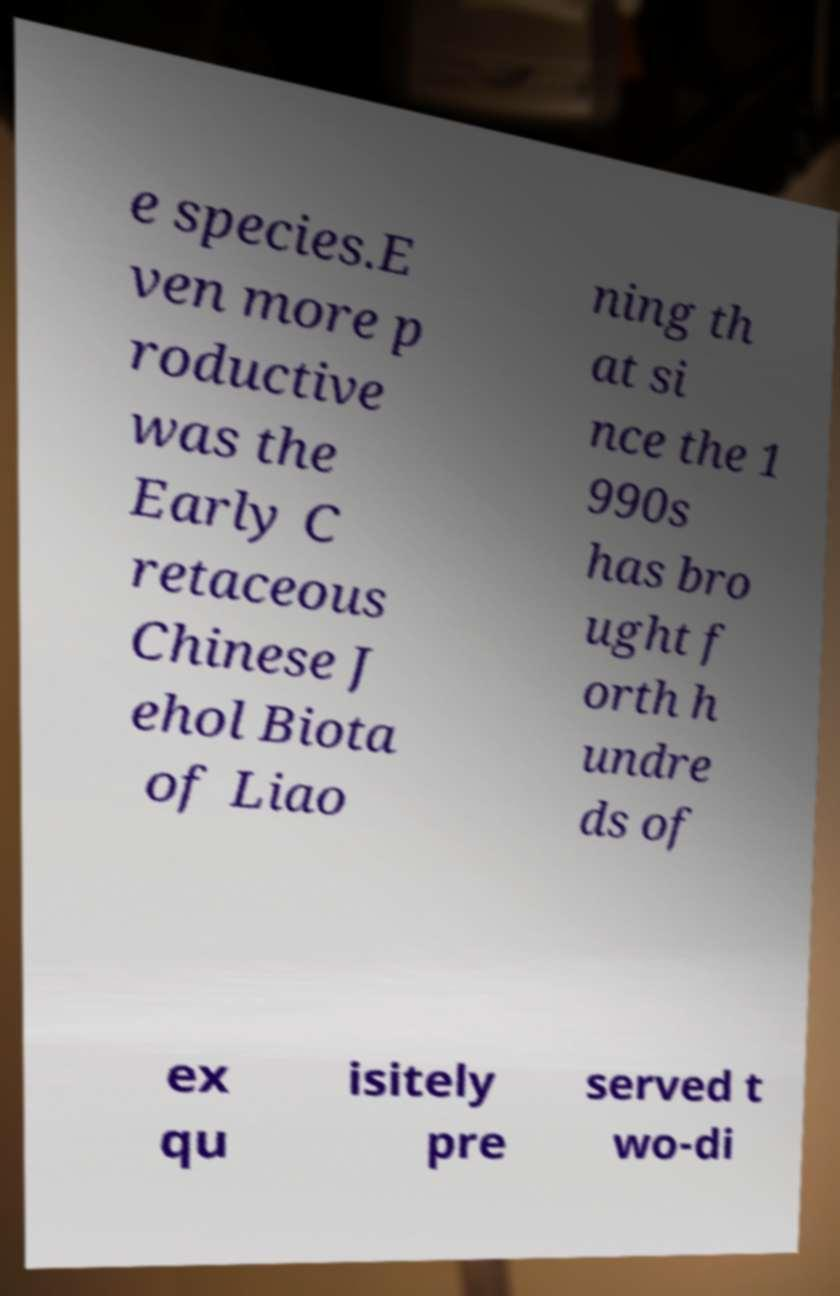For documentation purposes, I need the text within this image transcribed. Could you provide that? e species.E ven more p roductive was the Early C retaceous Chinese J ehol Biota of Liao ning th at si nce the 1 990s has bro ught f orth h undre ds of ex qu isitely pre served t wo-di 